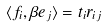<formula> <loc_0><loc_0><loc_500><loc_500>\langle f _ { i } , \beta e _ { j } \rangle = t _ { i } r _ { i j }</formula> 